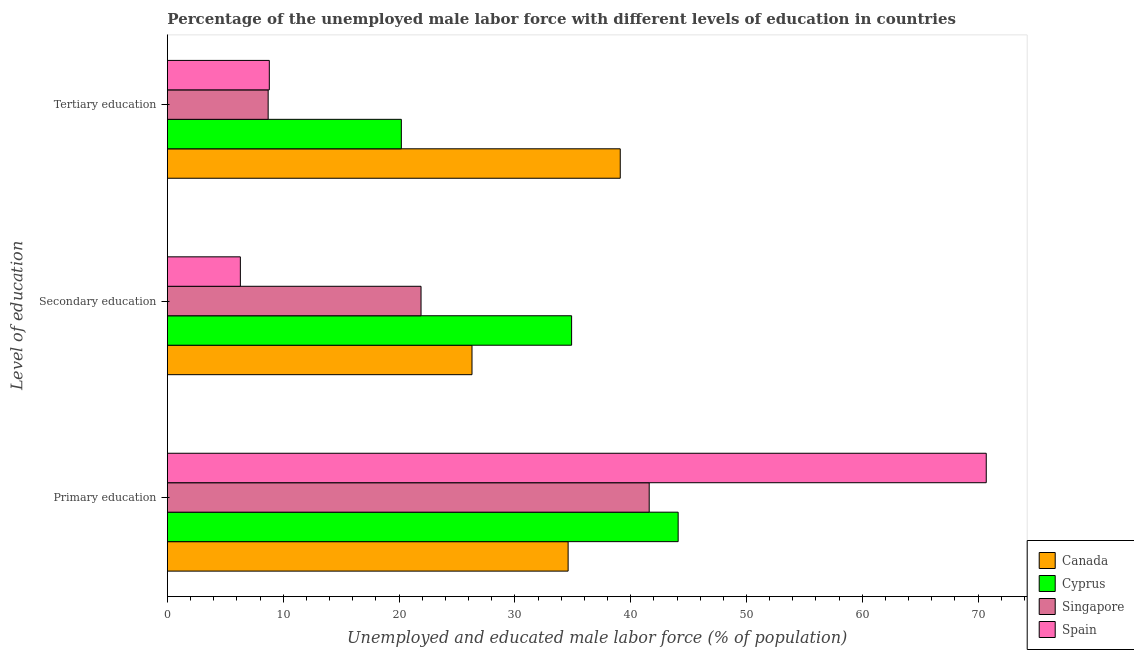Are the number of bars per tick equal to the number of legend labels?
Make the answer very short. Yes. How many bars are there on the 3rd tick from the bottom?
Ensure brevity in your answer.  4. What is the percentage of male labor force who received tertiary education in Canada?
Your answer should be compact. 39.1. Across all countries, what is the maximum percentage of male labor force who received secondary education?
Offer a terse response. 34.9. Across all countries, what is the minimum percentage of male labor force who received tertiary education?
Give a very brief answer. 8.7. In which country was the percentage of male labor force who received secondary education maximum?
Make the answer very short. Cyprus. What is the total percentage of male labor force who received primary education in the graph?
Offer a very short reply. 191. What is the difference between the percentage of male labor force who received secondary education in Cyprus and that in Canada?
Offer a terse response. 8.6. What is the difference between the percentage of male labor force who received secondary education in Singapore and the percentage of male labor force who received tertiary education in Canada?
Make the answer very short. -17.2. What is the average percentage of male labor force who received tertiary education per country?
Offer a terse response. 19.2. What is the difference between the percentage of male labor force who received secondary education and percentage of male labor force who received tertiary education in Spain?
Offer a terse response. -2.5. In how many countries, is the percentage of male labor force who received primary education greater than 54 %?
Make the answer very short. 1. What is the ratio of the percentage of male labor force who received tertiary education in Singapore to that in Cyprus?
Make the answer very short. 0.43. Is the difference between the percentage of male labor force who received primary education in Cyprus and Canada greater than the difference between the percentage of male labor force who received tertiary education in Cyprus and Canada?
Your response must be concise. Yes. What is the difference between the highest and the second highest percentage of male labor force who received tertiary education?
Your response must be concise. 18.9. What is the difference between the highest and the lowest percentage of male labor force who received secondary education?
Offer a terse response. 28.6. Is the sum of the percentage of male labor force who received tertiary education in Cyprus and Spain greater than the maximum percentage of male labor force who received secondary education across all countries?
Offer a very short reply. No. What does the 3rd bar from the top in Primary education represents?
Keep it short and to the point. Cyprus. What does the 3rd bar from the bottom in Secondary education represents?
Your answer should be compact. Singapore. Is it the case that in every country, the sum of the percentage of male labor force who received primary education and percentage of male labor force who received secondary education is greater than the percentage of male labor force who received tertiary education?
Your response must be concise. Yes. What is the difference between two consecutive major ticks on the X-axis?
Your answer should be very brief. 10. Are the values on the major ticks of X-axis written in scientific E-notation?
Provide a succinct answer. No. How many legend labels are there?
Provide a short and direct response. 4. What is the title of the graph?
Make the answer very short. Percentage of the unemployed male labor force with different levels of education in countries. Does "Liechtenstein" appear as one of the legend labels in the graph?
Give a very brief answer. No. What is the label or title of the X-axis?
Your answer should be compact. Unemployed and educated male labor force (% of population). What is the label or title of the Y-axis?
Your response must be concise. Level of education. What is the Unemployed and educated male labor force (% of population) in Canada in Primary education?
Keep it short and to the point. 34.6. What is the Unemployed and educated male labor force (% of population) of Cyprus in Primary education?
Provide a short and direct response. 44.1. What is the Unemployed and educated male labor force (% of population) of Singapore in Primary education?
Your answer should be compact. 41.6. What is the Unemployed and educated male labor force (% of population) of Spain in Primary education?
Your response must be concise. 70.7. What is the Unemployed and educated male labor force (% of population) in Canada in Secondary education?
Give a very brief answer. 26.3. What is the Unemployed and educated male labor force (% of population) of Cyprus in Secondary education?
Provide a short and direct response. 34.9. What is the Unemployed and educated male labor force (% of population) in Singapore in Secondary education?
Give a very brief answer. 21.9. What is the Unemployed and educated male labor force (% of population) of Spain in Secondary education?
Ensure brevity in your answer.  6.3. What is the Unemployed and educated male labor force (% of population) in Canada in Tertiary education?
Keep it short and to the point. 39.1. What is the Unemployed and educated male labor force (% of population) of Cyprus in Tertiary education?
Your response must be concise. 20.2. What is the Unemployed and educated male labor force (% of population) of Singapore in Tertiary education?
Ensure brevity in your answer.  8.7. What is the Unemployed and educated male labor force (% of population) of Spain in Tertiary education?
Keep it short and to the point. 8.8. Across all Level of education, what is the maximum Unemployed and educated male labor force (% of population) in Canada?
Make the answer very short. 39.1. Across all Level of education, what is the maximum Unemployed and educated male labor force (% of population) of Cyprus?
Give a very brief answer. 44.1. Across all Level of education, what is the maximum Unemployed and educated male labor force (% of population) of Singapore?
Ensure brevity in your answer.  41.6. Across all Level of education, what is the maximum Unemployed and educated male labor force (% of population) in Spain?
Provide a succinct answer. 70.7. Across all Level of education, what is the minimum Unemployed and educated male labor force (% of population) in Canada?
Keep it short and to the point. 26.3. Across all Level of education, what is the minimum Unemployed and educated male labor force (% of population) of Cyprus?
Provide a short and direct response. 20.2. Across all Level of education, what is the minimum Unemployed and educated male labor force (% of population) of Singapore?
Give a very brief answer. 8.7. Across all Level of education, what is the minimum Unemployed and educated male labor force (% of population) of Spain?
Offer a very short reply. 6.3. What is the total Unemployed and educated male labor force (% of population) of Canada in the graph?
Keep it short and to the point. 100. What is the total Unemployed and educated male labor force (% of population) in Cyprus in the graph?
Ensure brevity in your answer.  99.2. What is the total Unemployed and educated male labor force (% of population) in Singapore in the graph?
Give a very brief answer. 72.2. What is the total Unemployed and educated male labor force (% of population) in Spain in the graph?
Your answer should be compact. 85.8. What is the difference between the Unemployed and educated male labor force (% of population) in Singapore in Primary education and that in Secondary education?
Provide a short and direct response. 19.7. What is the difference between the Unemployed and educated male labor force (% of population) in Spain in Primary education and that in Secondary education?
Provide a succinct answer. 64.4. What is the difference between the Unemployed and educated male labor force (% of population) of Cyprus in Primary education and that in Tertiary education?
Offer a very short reply. 23.9. What is the difference between the Unemployed and educated male labor force (% of population) in Singapore in Primary education and that in Tertiary education?
Provide a succinct answer. 32.9. What is the difference between the Unemployed and educated male labor force (% of population) in Spain in Primary education and that in Tertiary education?
Provide a succinct answer. 61.9. What is the difference between the Unemployed and educated male labor force (% of population) of Canada in Secondary education and that in Tertiary education?
Give a very brief answer. -12.8. What is the difference between the Unemployed and educated male labor force (% of population) in Singapore in Secondary education and that in Tertiary education?
Your answer should be compact. 13.2. What is the difference between the Unemployed and educated male labor force (% of population) in Canada in Primary education and the Unemployed and educated male labor force (% of population) in Singapore in Secondary education?
Ensure brevity in your answer.  12.7. What is the difference between the Unemployed and educated male labor force (% of population) in Canada in Primary education and the Unemployed and educated male labor force (% of population) in Spain in Secondary education?
Provide a succinct answer. 28.3. What is the difference between the Unemployed and educated male labor force (% of population) in Cyprus in Primary education and the Unemployed and educated male labor force (% of population) in Singapore in Secondary education?
Provide a short and direct response. 22.2. What is the difference between the Unemployed and educated male labor force (% of population) in Cyprus in Primary education and the Unemployed and educated male labor force (% of population) in Spain in Secondary education?
Your answer should be compact. 37.8. What is the difference between the Unemployed and educated male labor force (% of population) in Singapore in Primary education and the Unemployed and educated male labor force (% of population) in Spain in Secondary education?
Give a very brief answer. 35.3. What is the difference between the Unemployed and educated male labor force (% of population) of Canada in Primary education and the Unemployed and educated male labor force (% of population) of Cyprus in Tertiary education?
Offer a terse response. 14.4. What is the difference between the Unemployed and educated male labor force (% of population) in Canada in Primary education and the Unemployed and educated male labor force (% of population) in Singapore in Tertiary education?
Provide a succinct answer. 25.9. What is the difference between the Unemployed and educated male labor force (% of population) of Canada in Primary education and the Unemployed and educated male labor force (% of population) of Spain in Tertiary education?
Make the answer very short. 25.8. What is the difference between the Unemployed and educated male labor force (% of population) of Cyprus in Primary education and the Unemployed and educated male labor force (% of population) of Singapore in Tertiary education?
Ensure brevity in your answer.  35.4. What is the difference between the Unemployed and educated male labor force (% of population) of Cyprus in Primary education and the Unemployed and educated male labor force (% of population) of Spain in Tertiary education?
Give a very brief answer. 35.3. What is the difference between the Unemployed and educated male labor force (% of population) of Singapore in Primary education and the Unemployed and educated male labor force (% of population) of Spain in Tertiary education?
Ensure brevity in your answer.  32.8. What is the difference between the Unemployed and educated male labor force (% of population) of Cyprus in Secondary education and the Unemployed and educated male labor force (% of population) of Singapore in Tertiary education?
Provide a short and direct response. 26.2. What is the difference between the Unemployed and educated male labor force (% of population) of Cyprus in Secondary education and the Unemployed and educated male labor force (% of population) of Spain in Tertiary education?
Provide a short and direct response. 26.1. What is the difference between the Unemployed and educated male labor force (% of population) in Singapore in Secondary education and the Unemployed and educated male labor force (% of population) in Spain in Tertiary education?
Your response must be concise. 13.1. What is the average Unemployed and educated male labor force (% of population) in Canada per Level of education?
Offer a terse response. 33.33. What is the average Unemployed and educated male labor force (% of population) of Cyprus per Level of education?
Your answer should be compact. 33.07. What is the average Unemployed and educated male labor force (% of population) in Singapore per Level of education?
Offer a terse response. 24.07. What is the average Unemployed and educated male labor force (% of population) of Spain per Level of education?
Your answer should be very brief. 28.6. What is the difference between the Unemployed and educated male labor force (% of population) in Canada and Unemployed and educated male labor force (% of population) in Cyprus in Primary education?
Make the answer very short. -9.5. What is the difference between the Unemployed and educated male labor force (% of population) of Canada and Unemployed and educated male labor force (% of population) of Spain in Primary education?
Give a very brief answer. -36.1. What is the difference between the Unemployed and educated male labor force (% of population) in Cyprus and Unemployed and educated male labor force (% of population) in Spain in Primary education?
Offer a very short reply. -26.6. What is the difference between the Unemployed and educated male labor force (% of population) of Singapore and Unemployed and educated male labor force (% of population) of Spain in Primary education?
Make the answer very short. -29.1. What is the difference between the Unemployed and educated male labor force (% of population) in Canada and Unemployed and educated male labor force (% of population) in Cyprus in Secondary education?
Provide a succinct answer. -8.6. What is the difference between the Unemployed and educated male labor force (% of population) of Cyprus and Unemployed and educated male labor force (% of population) of Spain in Secondary education?
Keep it short and to the point. 28.6. What is the difference between the Unemployed and educated male labor force (% of population) of Singapore and Unemployed and educated male labor force (% of population) of Spain in Secondary education?
Keep it short and to the point. 15.6. What is the difference between the Unemployed and educated male labor force (% of population) of Canada and Unemployed and educated male labor force (% of population) of Cyprus in Tertiary education?
Give a very brief answer. 18.9. What is the difference between the Unemployed and educated male labor force (% of population) in Canada and Unemployed and educated male labor force (% of population) in Singapore in Tertiary education?
Give a very brief answer. 30.4. What is the difference between the Unemployed and educated male labor force (% of population) of Canada and Unemployed and educated male labor force (% of population) of Spain in Tertiary education?
Your answer should be compact. 30.3. What is the difference between the Unemployed and educated male labor force (% of population) in Cyprus and Unemployed and educated male labor force (% of population) in Singapore in Tertiary education?
Offer a very short reply. 11.5. What is the difference between the Unemployed and educated male labor force (% of population) of Cyprus and Unemployed and educated male labor force (% of population) of Spain in Tertiary education?
Offer a terse response. 11.4. What is the ratio of the Unemployed and educated male labor force (% of population) in Canada in Primary education to that in Secondary education?
Offer a very short reply. 1.32. What is the ratio of the Unemployed and educated male labor force (% of population) in Cyprus in Primary education to that in Secondary education?
Provide a succinct answer. 1.26. What is the ratio of the Unemployed and educated male labor force (% of population) of Singapore in Primary education to that in Secondary education?
Your response must be concise. 1.9. What is the ratio of the Unemployed and educated male labor force (% of population) in Spain in Primary education to that in Secondary education?
Give a very brief answer. 11.22. What is the ratio of the Unemployed and educated male labor force (% of population) in Canada in Primary education to that in Tertiary education?
Offer a terse response. 0.88. What is the ratio of the Unemployed and educated male labor force (% of population) of Cyprus in Primary education to that in Tertiary education?
Give a very brief answer. 2.18. What is the ratio of the Unemployed and educated male labor force (% of population) of Singapore in Primary education to that in Tertiary education?
Make the answer very short. 4.78. What is the ratio of the Unemployed and educated male labor force (% of population) in Spain in Primary education to that in Tertiary education?
Your answer should be very brief. 8.03. What is the ratio of the Unemployed and educated male labor force (% of population) in Canada in Secondary education to that in Tertiary education?
Your answer should be very brief. 0.67. What is the ratio of the Unemployed and educated male labor force (% of population) in Cyprus in Secondary education to that in Tertiary education?
Provide a short and direct response. 1.73. What is the ratio of the Unemployed and educated male labor force (% of population) in Singapore in Secondary education to that in Tertiary education?
Give a very brief answer. 2.52. What is the ratio of the Unemployed and educated male labor force (% of population) of Spain in Secondary education to that in Tertiary education?
Offer a very short reply. 0.72. What is the difference between the highest and the second highest Unemployed and educated male labor force (% of population) of Spain?
Offer a terse response. 61.9. What is the difference between the highest and the lowest Unemployed and educated male labor force (% of population) of Canada?
Make the answer very short. 12.8. What is the difference between the highest and the lowest Unemployed and educated male labor force (% of population) of Cyprus?
Your answer should be very brief. 23.9. What is the difference between the highest and the lowest Unemployed and educated male labor force (% of population) of Singapore?
Your answer should be very brief. 32.9. What is the difference between the highest and the lowest Unemployed and educated male labor force (% of population) in Spain?
Provide a succinct answer. 64.4. 